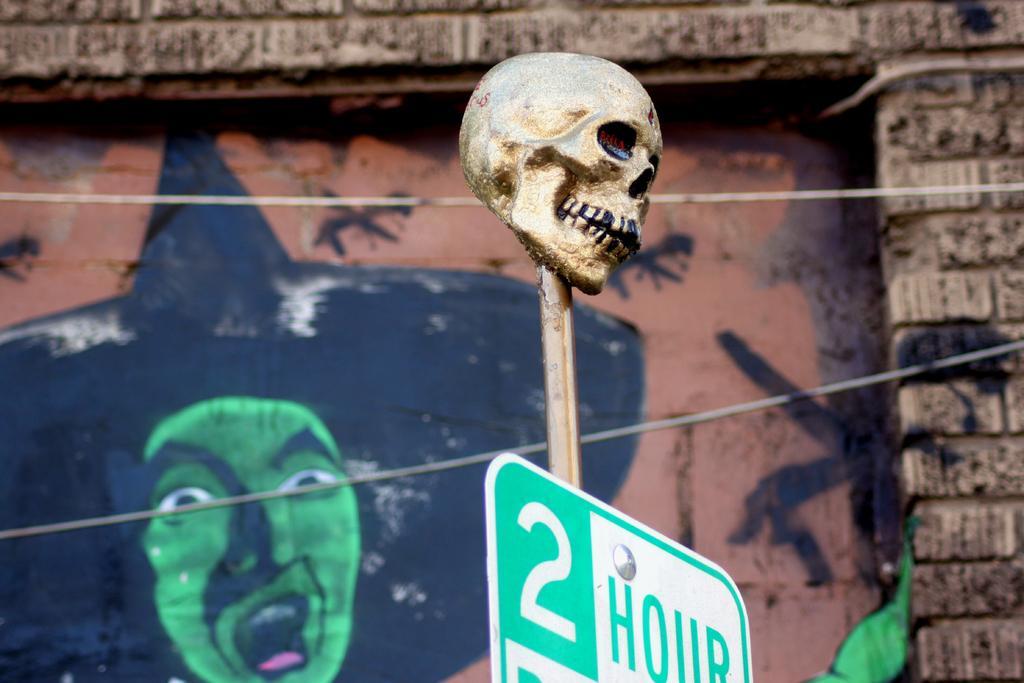What is the main object in the foreground of the image? There is a metal skull on a pole in the foreground of the image. What is located at the bottom of the image? There is a board at the bottom of the image. What can be seen in the background of the image? Cables are visible in the background of the image, and there is a painting on the wall. What does the rat say in the image? There is no rat present in the image, so it cannot be determined what the rat might say. 